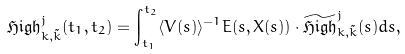<formula> <loc_0><loc_0><loc_500><loc_500>\mathfrak { H i g h } ^ { j } _ { k , \tilde { k } } ( t _ { 1 } , t _ { 2 } ) = \int _ { t _ { 1 } } ^ { t _ { 2 } } \langle V ( s ) \rangle ^ { - 1 } E ( s , X ( s ) ) \cdot \widetilde { \mathfrak { H i g h } } ^ { j } _ { k , \tilde { k } } ( s ) d s ,</formula> 